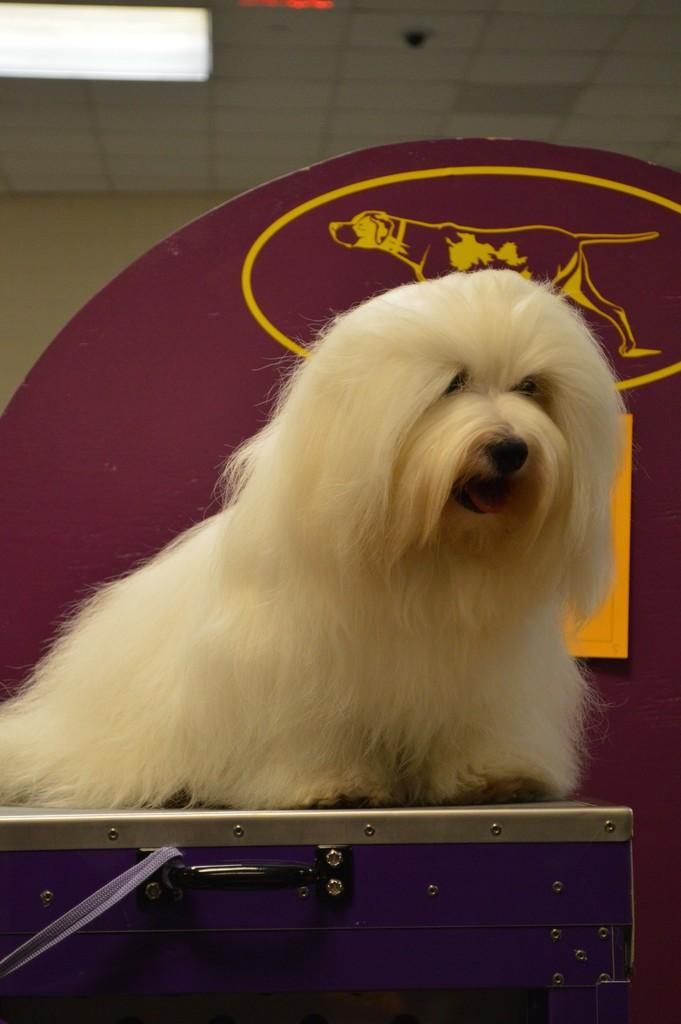What type of animal is in the image? There is a white dog in the image. What is the dog standing on? The dog is standing on a box. What can be seen in the background of the image? There is a board and a light in the ceiling in the background of the image. How much money does the dog have in the image? There is no indication of money or any financial transaction in the image. The focus is on the dog, its position, and the background elements. 